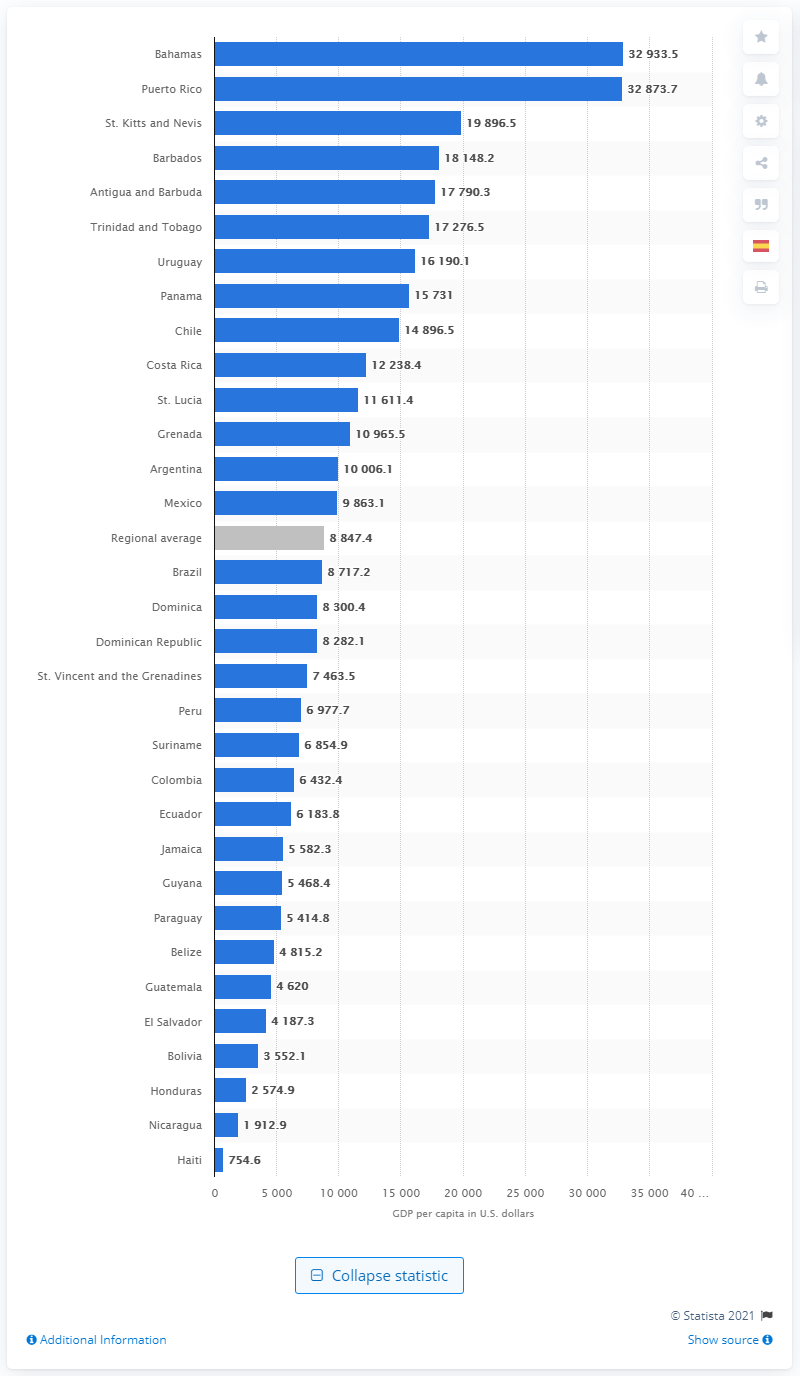List a handful of essential elements in this visual. Haiti had the lowest GDP per capita among all countries. 